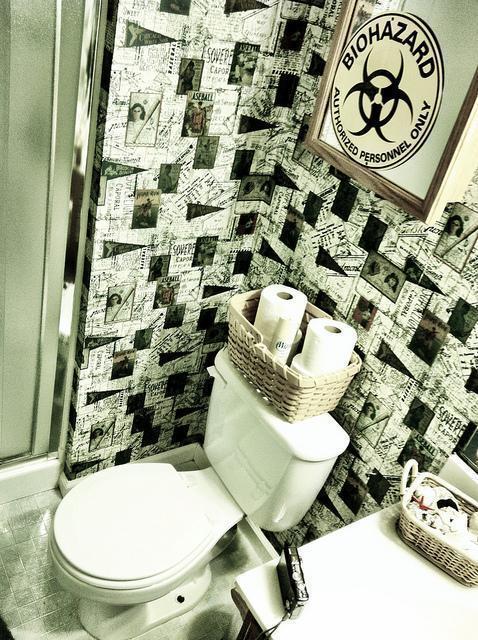What does the sign say?
Choose the correct response and explain in the format: 'Answer: answer
Rationale: rationale.'
Options: Biohazard, stop, garbage, proceed. Answer: biohazard.
Rationale: The sign says that it's biohazard. 